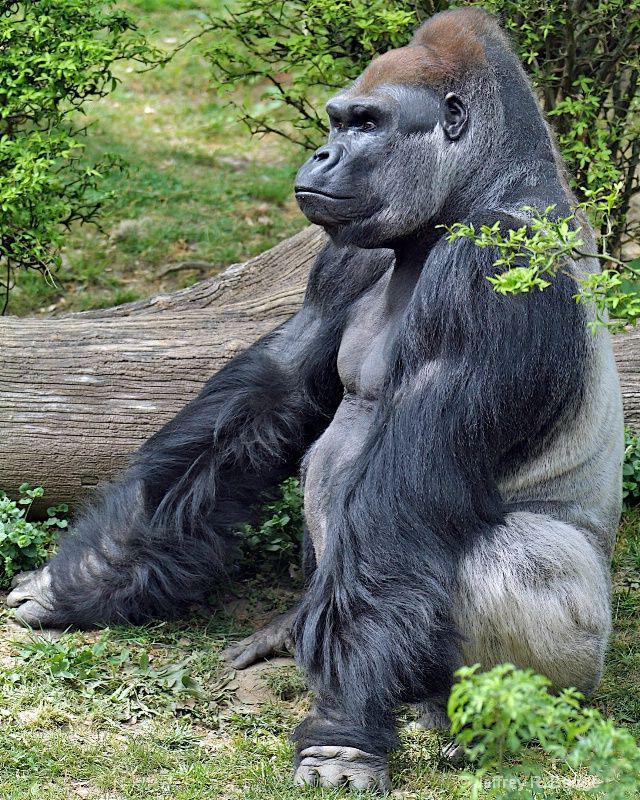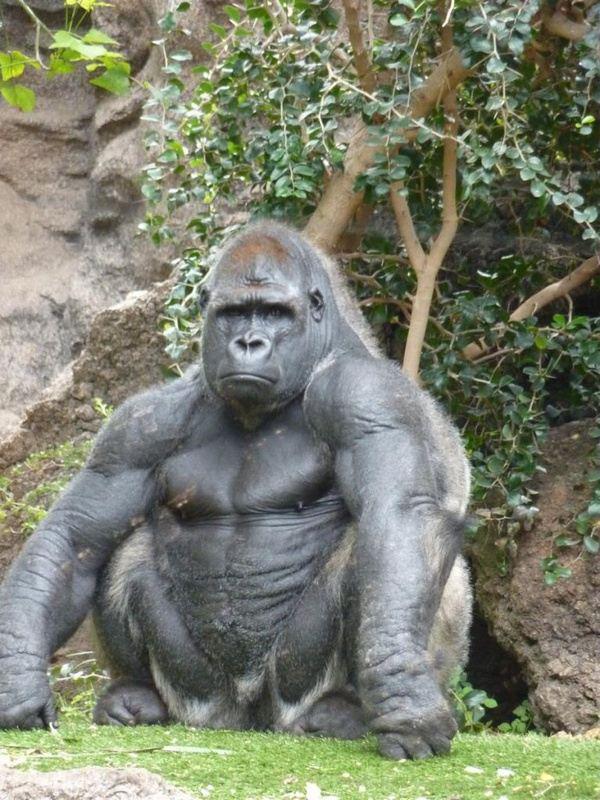The first image is the image on the left, the second image is the image on the right. Assess this claim about the two images: "In one of the pictures, a baby gorilla is near an adult gorilla.". Correct or not? Answer yes or no. No. The first image is the image on the left, the second image is the image on the right. Given the left and right images, does the statement "Each image contains the same number of gorillas." hold true? Answer yes or no. Yes. 